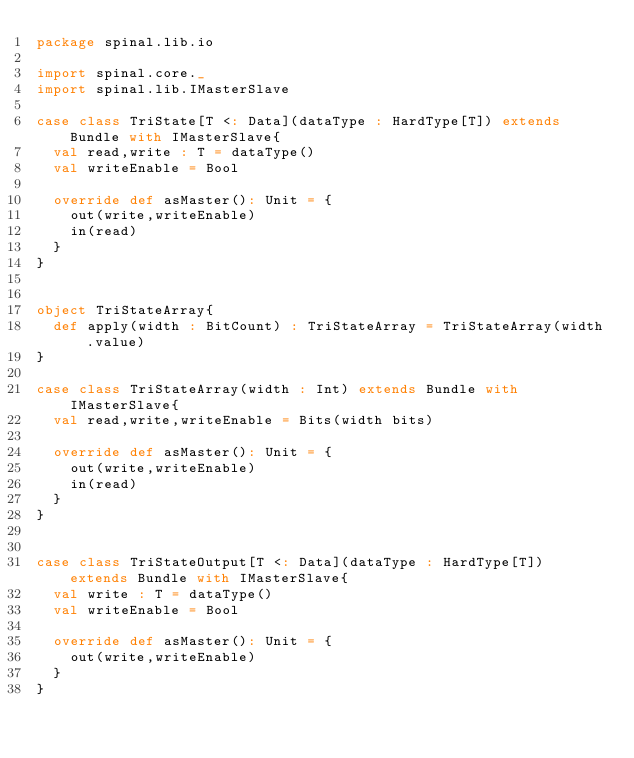Convert code to text. <code><loc_0><loc_0><loc_500><loc_500><_Scala_>package spinal.lib.io

import spinal.core._
import spinal.lib.IMasterSlave

case class TriState[T <: Data](dataType : HardType[T]) extends Bundle with IMasterSlave{
  val read,write : T = dataType()
  val writeEnable = Bool

  override def asMaster(): Unit = {
    out(write,writeEnable)
    in(read)
  }
}


object TriStateArray{
  def apply(width : BitCount) : TriStateArray = TriStateArray(width.value)
}

case class TriStateArray(width : Int) extends Bundle with IMasterSlave{
  val read,write,writeEnable = Bits(width bits)

  override def asMaster(): Unit = {
    out(write,writeEnable)
    in(read)
  }
}


case class TriStateOutput[T <: Data](dataType : HardType[T]) extends Bundle with IMasterSlave{
  val write : T = dataType()
  val writeEnable = Bool

  override def asMaster(): Unit = {
    out(write,writeEnable)
  }
}
</code> 